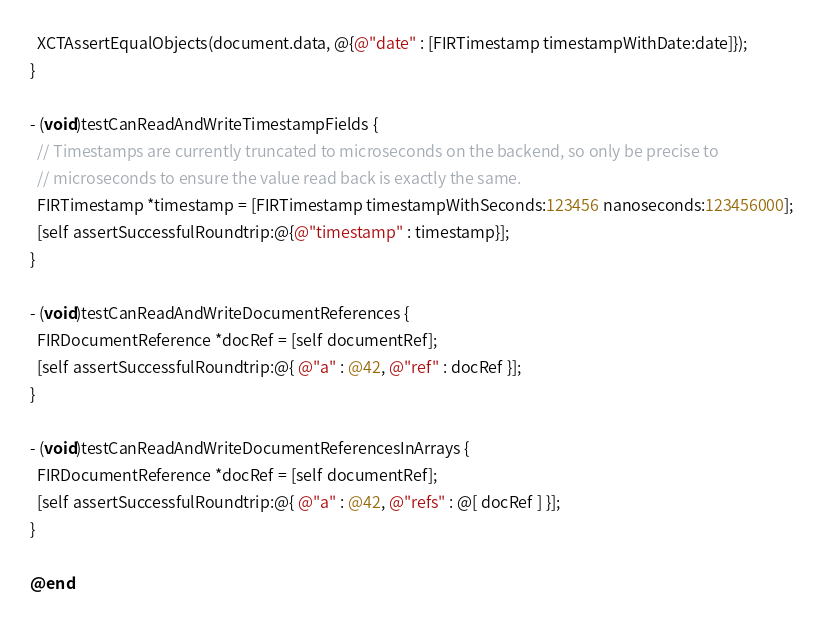Convert code to text. <code><loc_0><loc_0><loc_500><loc_500><_ObjectiveC_>  XCTAssertEqualObjects(document.data, @{@"date" : [FIRTimestamp timestampWithDate:date]});
}

- (void)testCanReadAndWriteTimestampFields {
  // Timestamps are currently truncated to microseconds on the backend, so only be precise to
  // microseconds to ensure the value read back is exactly the same.
  FIRTimestamp *timestamp = [FIRTimestamp timestampWithSeconds:123456 nanoseconds:123456000];
  [self assertSuccessfulRoundtrip:@{@"timestamp" : timestamp}];
}

- (void)testCanReadAndWriteDocumentReferences {
  FIRDocumentReference *docRef = [self documentRef];
  [self assertSuccessfulRoundtrip:@{ @"a" : @42, @"ref" : docRef }];
}

- (void)testCanReadAndWriteDocumentReferencesInArrays {
  FIRDocumentReference *docRef = [self documentRef];
  [self assertSuccessfulRoundtrip:@{ @"a" : @42, @"refs" : @[ docRef ] }];
}

@end
</code> 